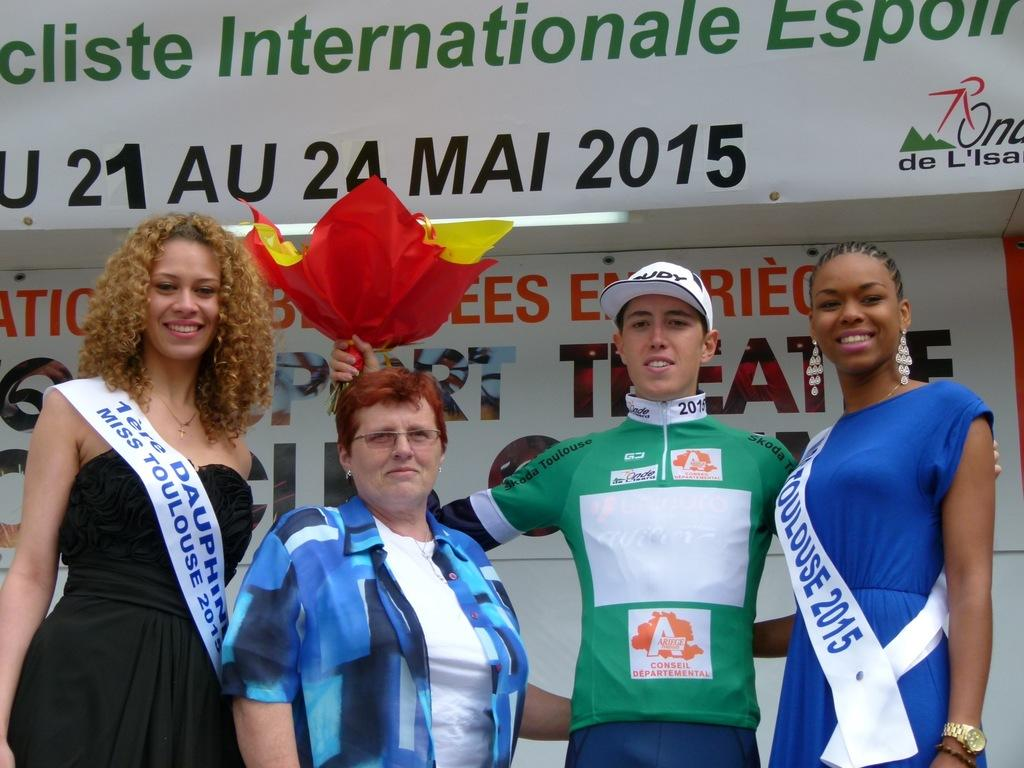<image>
Create a compact narrative representing the image presented. Four people pose for a picture, including Miss Toulouse 2015. 